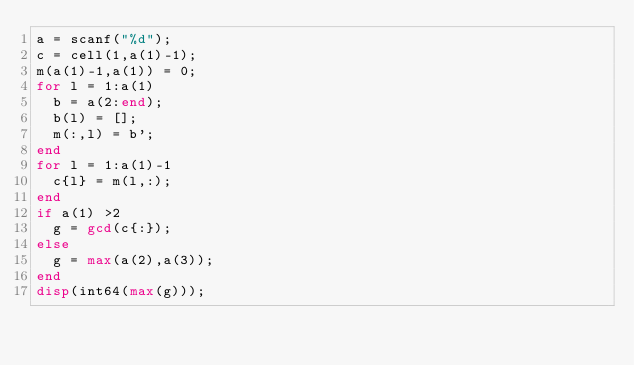<code> <loc_0><loc_0><loc_500><loc_500><_Octave_>a = scanf("%d");
c = cell(1,a(1)-1);
m(a(1)-1,a(1)) = 0;
for l = 1:a(1)
	b = a(2:end);
	b(l) = [];
	m(:,l) = b';
end
for l = 1:a(1)-1
  c{l} = m(l,:);
end
if a(1) >2
	g = gcd(c{:});
else
	g = max(a(2),a(3));
end
disp(int64(max(g)));
</code> 